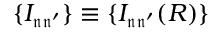Convert formula to latex. <formula><loc_0><loc_0><loc_500><loc_500>\{ I _ { \mathfrak { n } \mathfrak { n ^ { \prime } } } \} \equiv \{ I _ { \mathfrak { n } \mathfrak { n ^ { \prime } } } ( R ) \}</formula> 